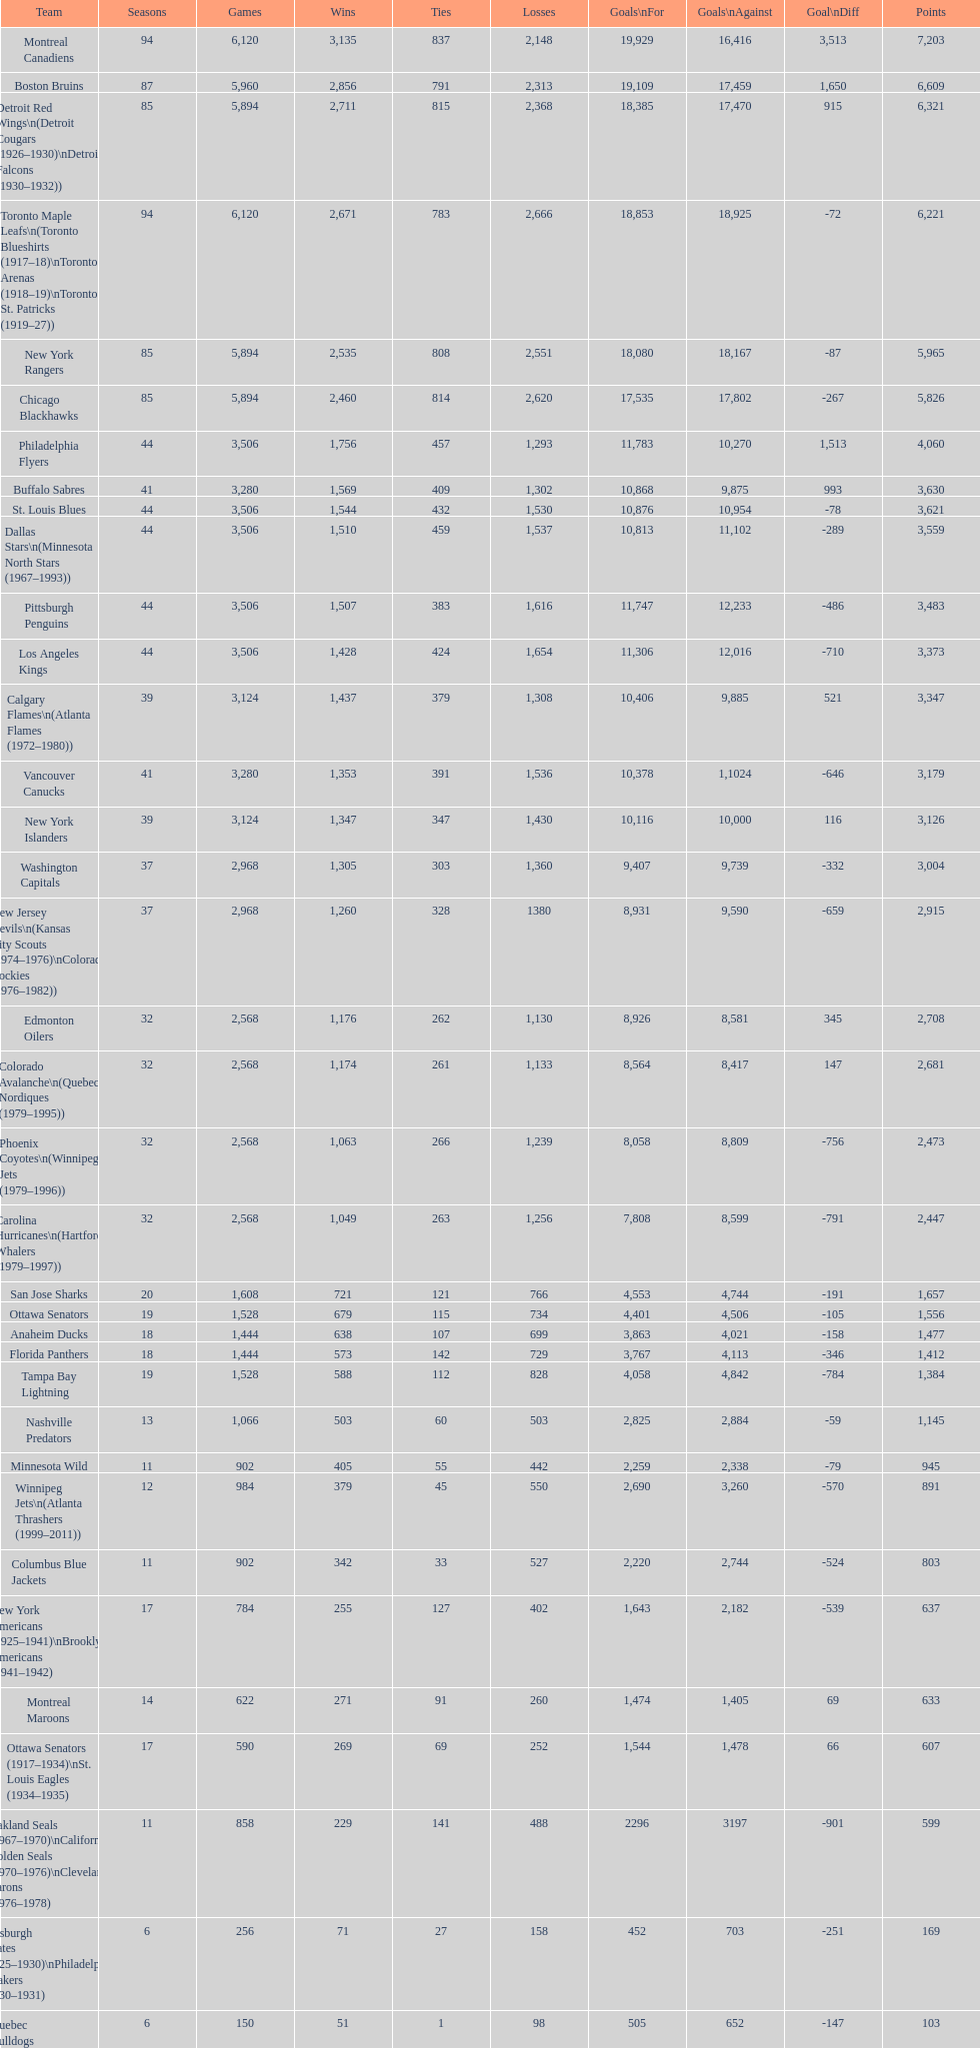How many losses do the st. louis blues have? 1,530. 